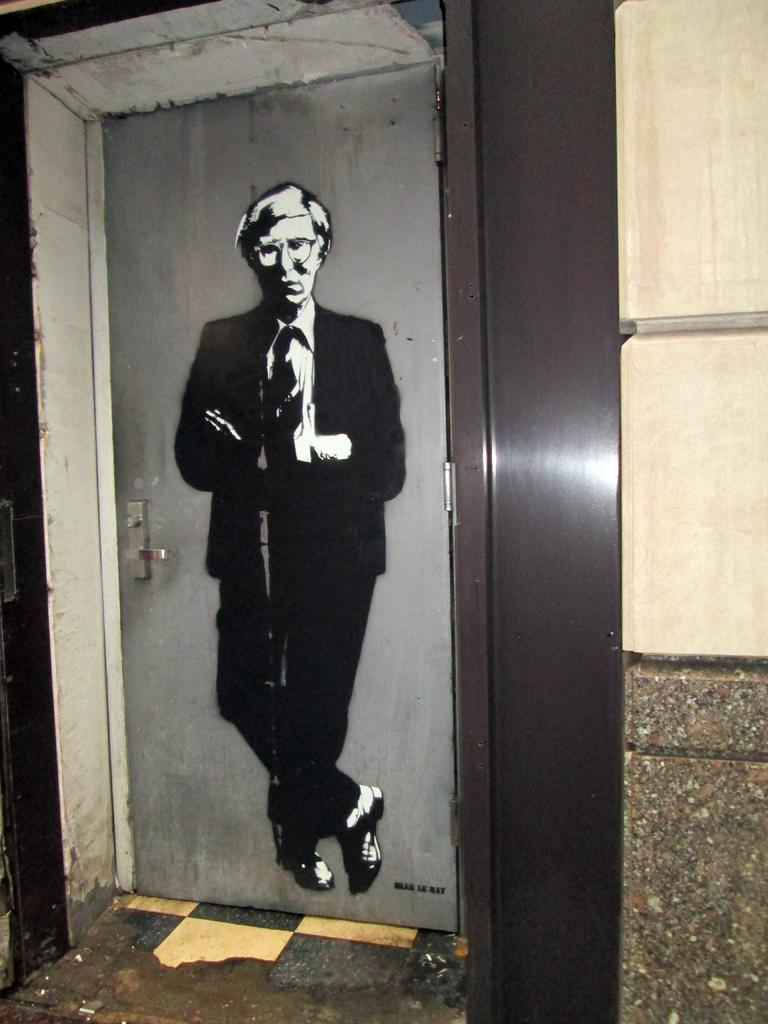What is depicted on the door in the image? There is a picture of a man on the door. What can be seen on the right side of the image? There is a wall on the right side of the image. What part of the room is visible at the bottom of the image? The floor is visible at the bottom of the image. How does the earthquake affect the man's picture on the door in the image? There is no earthquake present in the image, so its effects cannot be observed. 